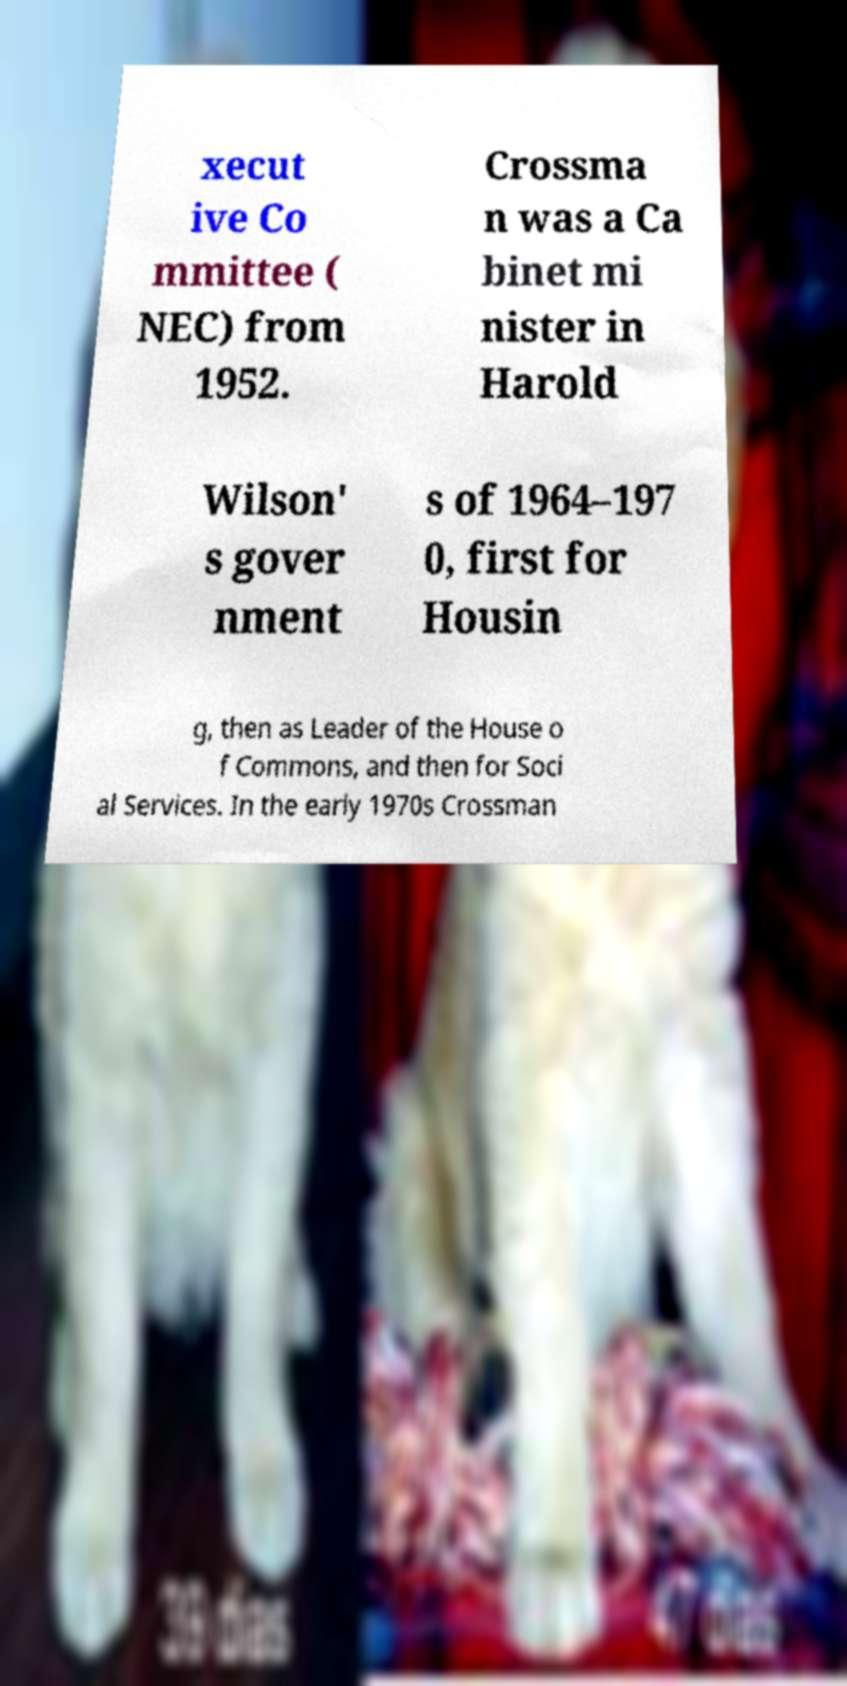For documentation purposes, I need the text within this image transcribed. Could you provide that? xecut ive Co mmittee ( NEC) from 1952. Crossma n was a Ca binet mi nister in Harold Wilson' s gover nment s of 1964–197 0, first for Housin g, then as Leader of the House o f Commons, and then for Soci al Services. In the early 1970s Crossman 